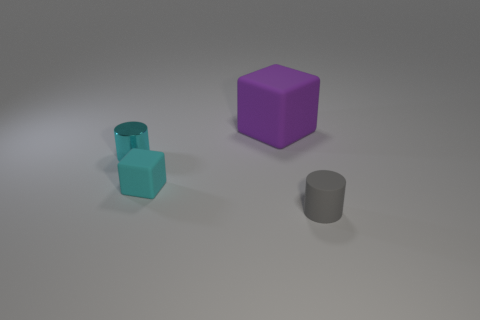Subtract 1 cylinders. How many cylinders are left? 1 Subtract all purple blocks. Subtract all green spheres. How many blocks are left? 1 Subtract all gray cylinders. How many red blocks are left? 0 Subtract all large gray rubber blocks. Subtract all purple matte objects. How many objects are left? 3 Add 1 cyan things. How many cyan things are left? 3 Add 3 tiny red balls. How many tiny red balls exist? 3 Add 3 small cubes. How many objects exist? 7 Subtract all gray cylinders. How many cylinders are left? 1 Subtract 0 red cubes. How many objects are left? 4 